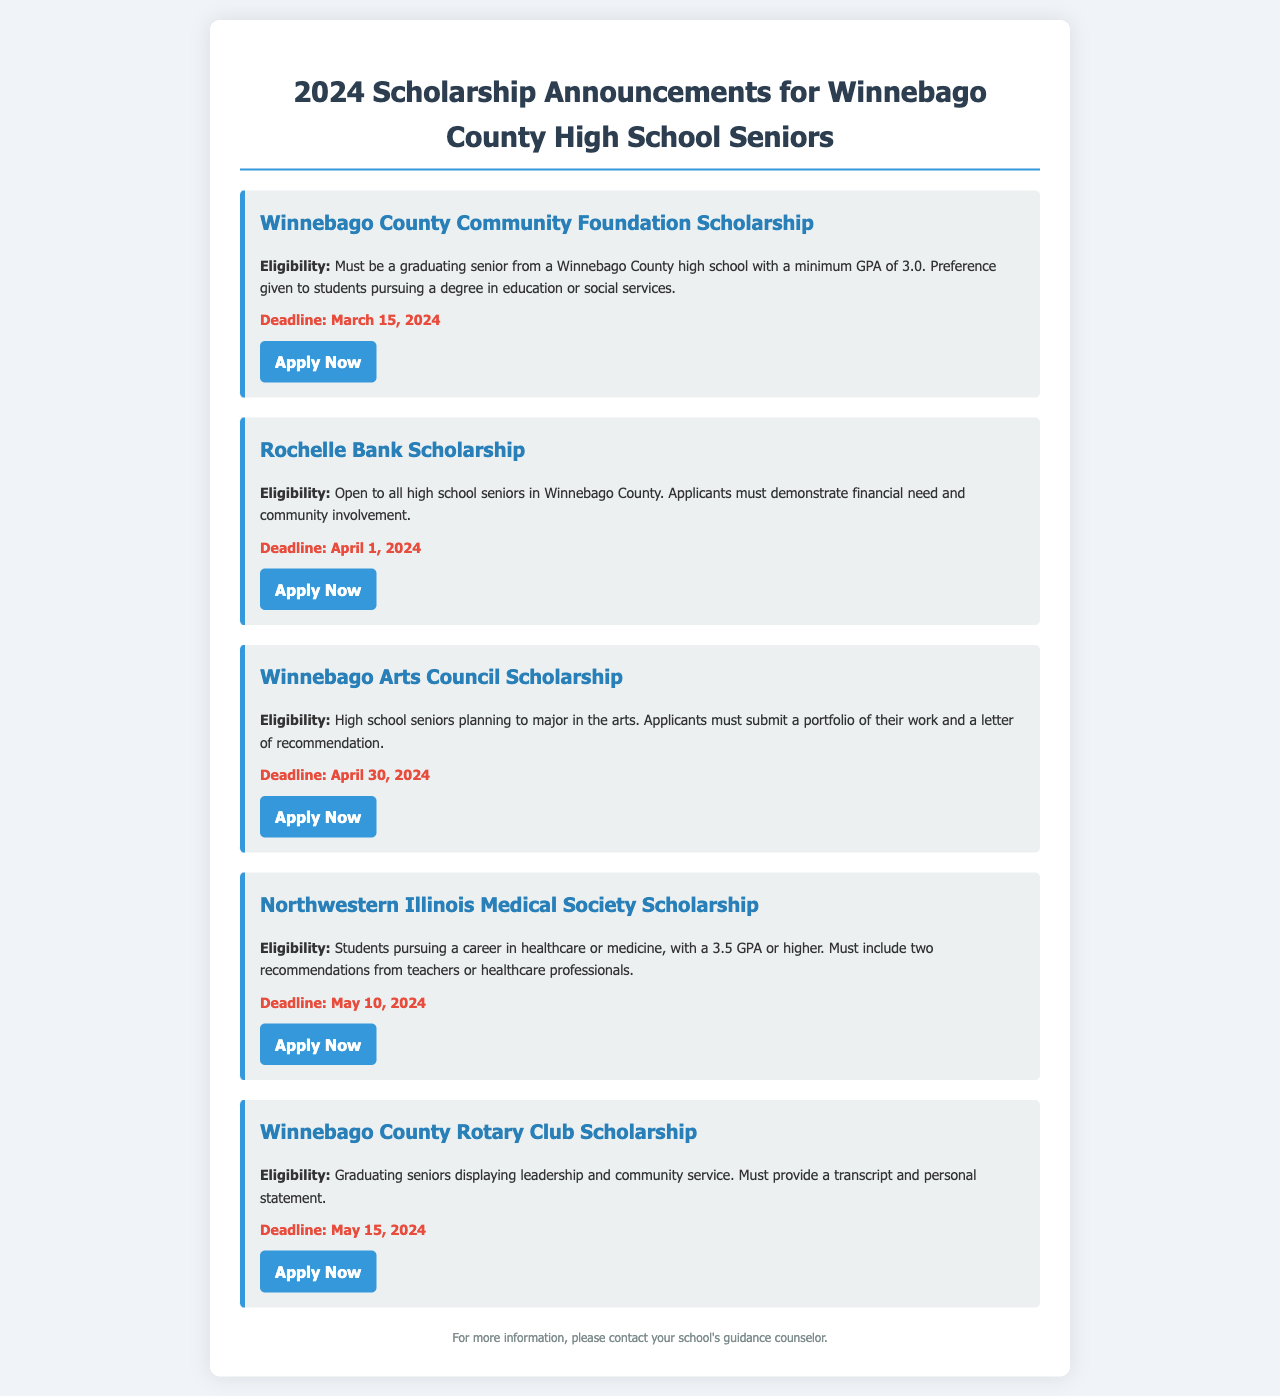What is the first scholarship listed? The first scholarship listed in the document is the Winnebago County Community Foundation Scholarship.
Answer: Winnebago County Community Foundation Scholarship What is the deadline for the Rochelle Bank Scholarship? The deadline for the Rochelle Bank Scholarship is mentioned in the document.
Answer: April 1, 2024 Who is eligible for the Winnebago Arts Council Scholarship? Eligibility for the Winnebago Arts Council Scholarship is specifically for students planning to major in the arts.
Answer: Students planning to major in the arts How many recommendations are required for the Northwestern Illinois Medical Society Scholarship? The number of recommendations required is stated in the eligibility criteria for the scholarship.
Answer: Two recommendations What is the minimum GPA requirement for the Winnebago County Community Foundation Scholarship? The minimum GPA requirement is specified in the eligibility criteria of the scholarship.
Answer: 3.0 Which scholarship has a preference for students pursuing education or social services? The preference for the field of study is indicated as part of the eligibility criteria for one of the scholarships.
Answer: Winnebago County Community Foundation Scholarship When is the application deadline for the Winnebago County Rotary Club Scholarship? The specific deadline for the Winnebago County Rotary Club Scholarship is clearly mentioned in the document.
Answer: May 15, 2024 Are the scholarships specific to any particular high school in Winnebago County? The document indicates that the scholarships are for all high school seniors in Winnebago County.
Answer: No What document must be submitted for the Winnebago County Rotary Club Scholarship? The requirement for the application includes a specific document to be submitted as stated in the eligibility criteria.
Answer: Transcript and personal statement 